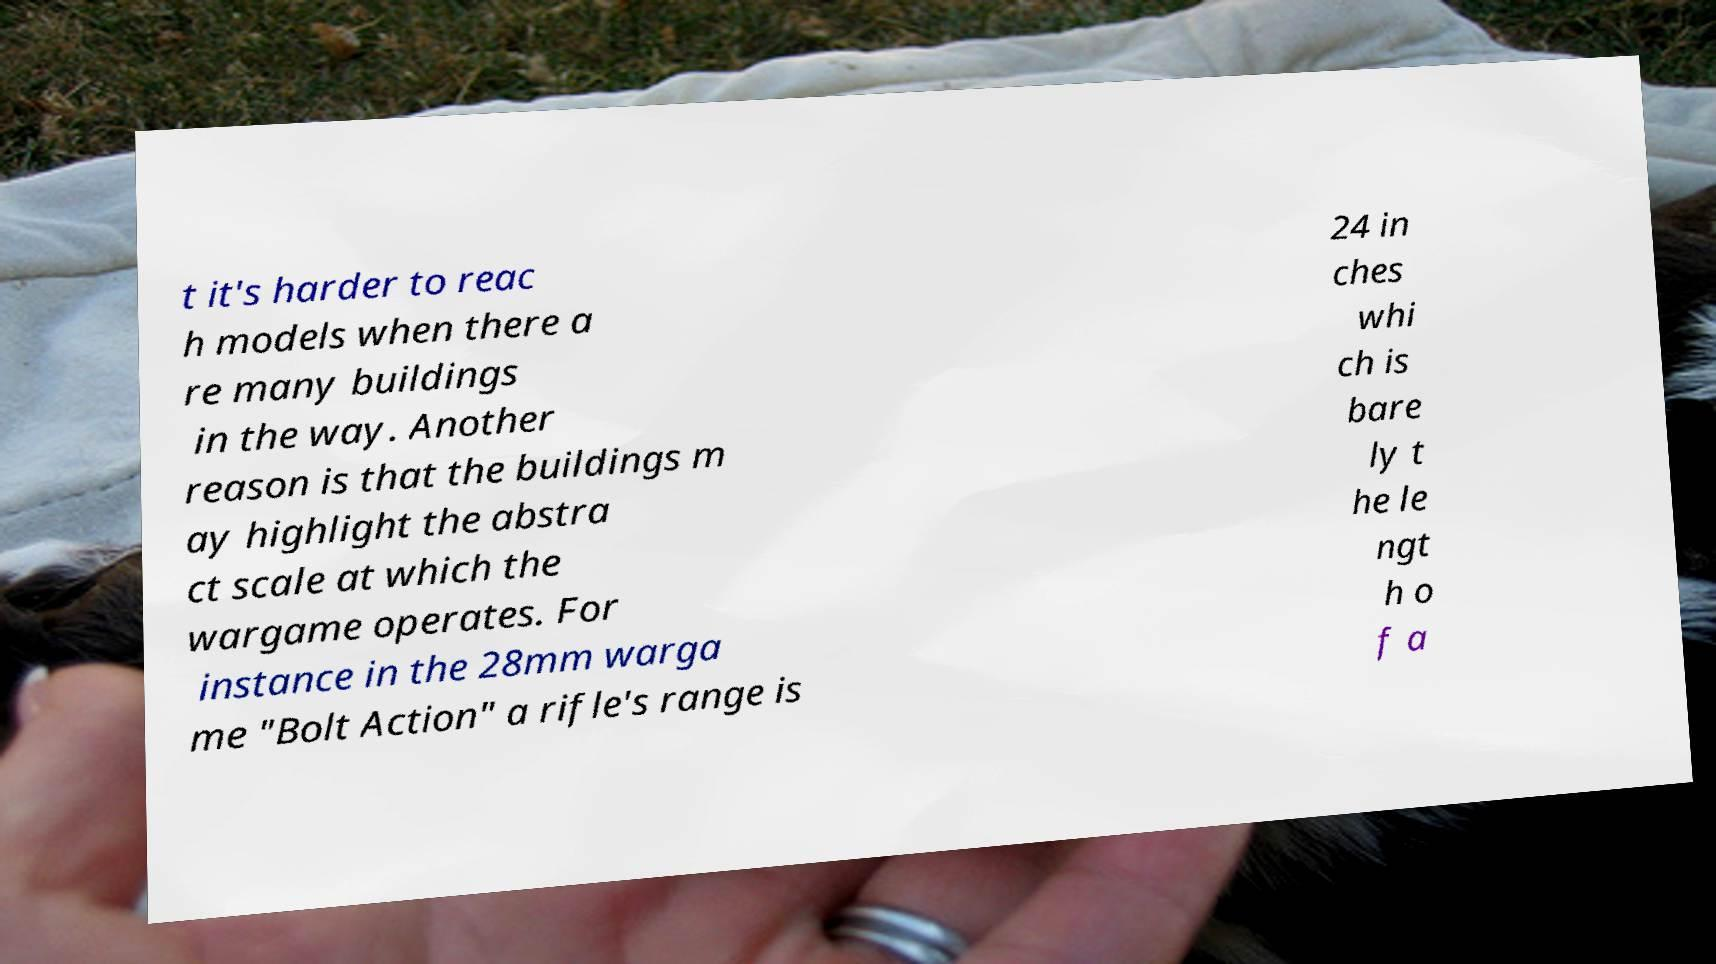Could you assist in decoding the text presented in this image and type it out clearly? t it's harder to reac h models when there a re many buildings in the way. Another reason is that the buildings m ay highlight the abstra ct scale at which the wargame operates. For instance in the 28mm warga me "Bolt Action" a rifle's range is 24 in ches whi ch is bare ly t he le ngt h o f a 